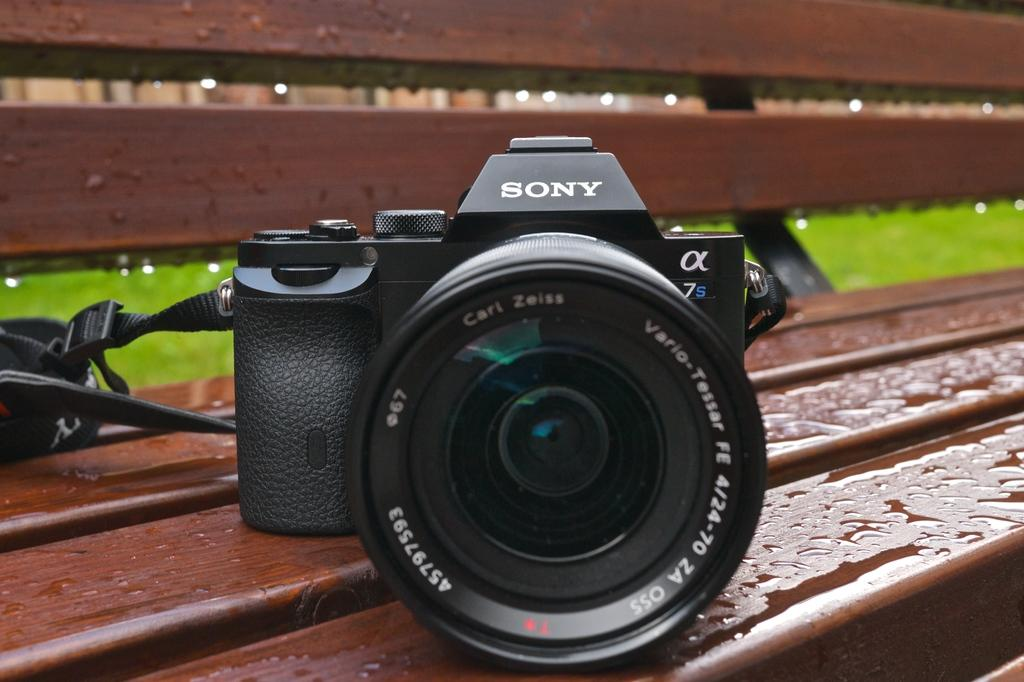What is the main object in the image? There is a camera in the image. Where is the camera placed? The camera is on a brown color bench. What type of natural environment can be seen in the image? There is grass visible in the image. Can you see any lace on the camera in the image? There is no lace present on the camera in the image. How many toes are visible in the image? There are no toes visible in the image; it features a camera on a bench with grass in the background. 